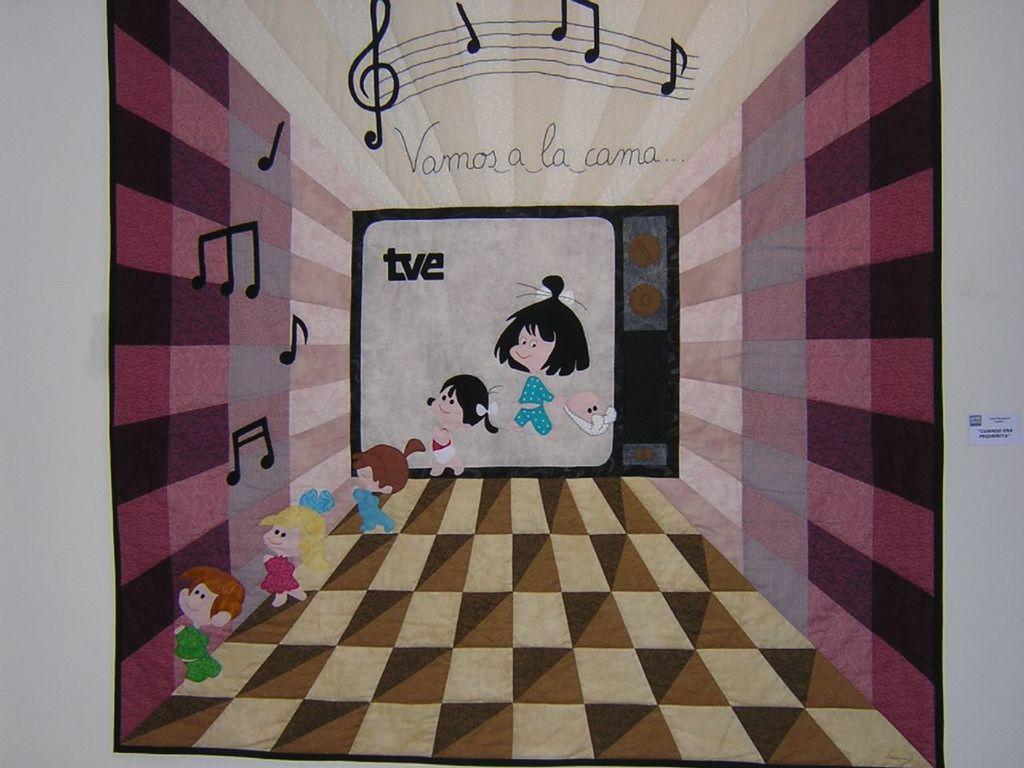What foreign sentence is on this art piece?
Ensure brevity in your answer.  Vamos a la cama. What are the 3 letters inside the tv?
Ensure brevity in your answer.  Tve. 